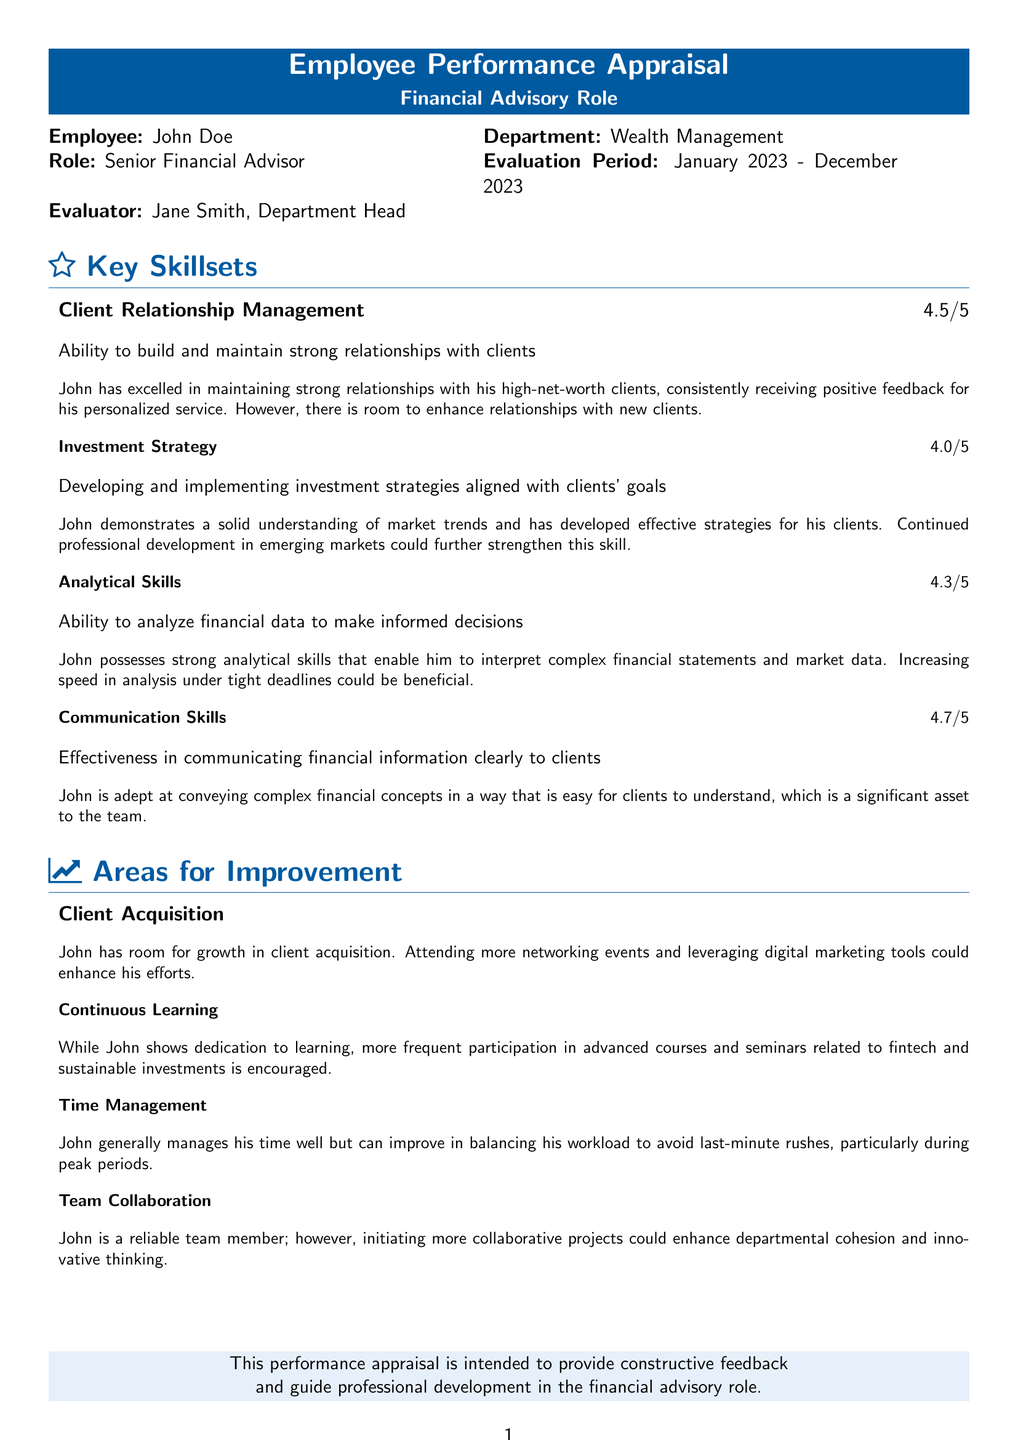What is the employee's name? The employee's name is mentioned right at the top of the document as John Doe.
Answer: John Doe What is the evaluation period? The evaluation period is clearly stated in the document, which specifies January 2023 to December 2023.
Answer: January 2023 - December 2023 What is the rating for Communication Skills? The rating for Communication Skills is provided alongside the skillset, which states 4.7 out of 5.
Answer: 4.7/5 What area has the highest rating? By comparing all skill ratings in the document, Communication Skills has the highest rating of 4.7 out of 5.
Answer: Communication Skills What is one area where John can improve? According to the document, one area for improvement mentioned is Client Acquisition.
Answer: Client Acquisition What skillset does John demonstrate in investment strategy? The document states that John has a solid understanding of market trends in investment strategy.
Answer: Solid understanding of market trends Which skillset has the lowest rating? The skillset with the lowest rating is Investment Strategy, which is rated at 4.0 out of 5.
Answer: Investment Strategy Who is the evaluator for this appraisal? The evaluator's name, as indicated on the document, is Jane Smith, the Department Head.
Answer: Jane Smith What is recommended for John's continuous learning? The recommendation for continuous learning suggests more frequent participation in advanced courses and seminars.
Answer: More frequent participation in advanced courses and seminars 